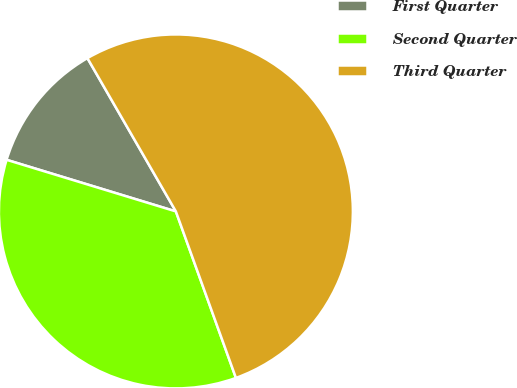Convert chart. <chart><loc_0><loc_0><loc_500><loc_500><pie_chart><fcel>First Quarter<fcel>Second Quarter<fcel>Third Quarter<nl><fcel>11.96%<fcel>35.22%<fcel>52.82%<nl></chart> 